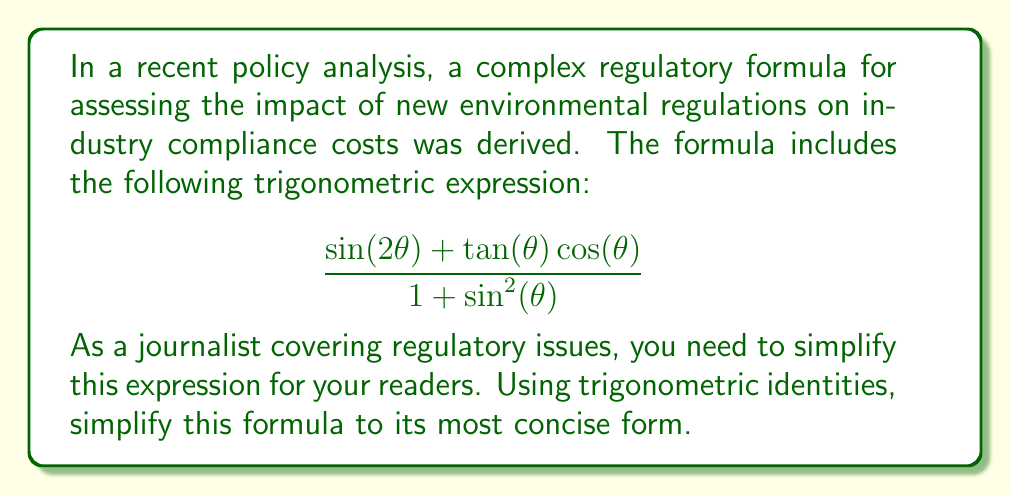Provide a solution to this math problem. Let's simplify this expression step by step using trigonometric identities:

1) First, let's focus on the numerator. We can simplify $\sin(2\theta)$ using the double angle formula:
   $$\sin(2\theta) = 2\sin(\theta)\cos(\theta)$$

2) Now our expression looks like this:
   $$\frac{2\sin(\theta)\cos(\theta) + \tan(\theta)\cos(\theta)}{1 + \sin^2(\theta)}$$

3) In the numerator, we can factor out $\cos(\theta)$:
   $$\frac{\cos(\theta)(2\sin(\theta) + \tan(\theta))}{1 + \sin^2(\theta)}$$

4) Recall that $\tan(\theta) = \frac{\sin(\theta)}{\cos(\theta)}$. Let's substitute this in:
   $$\frac{\cos(\theta)(2\sin(\theta) + \frac{\sin(\theta)}{\cos(\theta)})}{1 + \sin^2(\theta)}$$

5) Multiply both terms in the parentheses by $\cos(\theta)$:
   $$\frac{\cos(\theta)(2\sin(\theta)\cos(\theta) + \sin(\theta))}{1 + \sin^2(\theta)}$$

6) Factor out $\sin(\theta)$ from the numerator:
   $$\frac{\cos(\theta)\sin(\theta)(2\cos(\theta) + 1)}{1 + \sin^2(\theta)}$$

7) Now, let's look at the denominator. Recall the Pythagorean identity:
   $$\sin^2(\theta) + \cos^2(\theta) = 1$$
   
   This means that $1 + \sin^2(\theta) = 2 - \cos^2(\theta)$

8) Substituting this into our expression:
   $$\frac{\cos(\theta)\sin(\theta)(2\cos(\theta) + 1)}{2 - \cos^2(\theta)}$$

9) Finally, we can use the identity $\sin(2\theta) = 2\sin(\theta)\cos(\theta)$ again:
   $$\frac{\frac{1}{2}\sin(2\theta)(2\cos(\theta) + 1)}{2 - \cos^2(\theta)}$$

This is the most simplified form of the expression using standard trigonometric identities.
Answer: $$\frac{\frac{1}{2}\sin(2\theta)(2\cos(\theta) + 1)}{2 - \cos^2(\theta)}$$ 